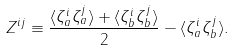Convert formula to latex. <formula><loc_0><loc_0><loc_500><loc_500>Z ^ { i j } \equiv \frac { \langle \zeta _ { a } ^ { i } \zeta _ { a } ^ { j } \rangle + \langle \zeta _ { b } ^ { i } \zeta _ { b } ^ { j } \rangle } { 2 } - \langle \zeta _ { a } ^ { i } \zeta _ { b } ^ { j } \rangle .</formula> 